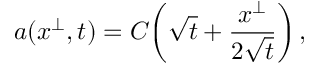<formula> <loc_0><loc_0><loc_500><loc_500>a ( x ^ { \perp } , t ) = C \, \left ( \sqrt { t } + \frac { x ^ { \perp } } { 2 \sqrt { t } } \right ) ,</formula> 